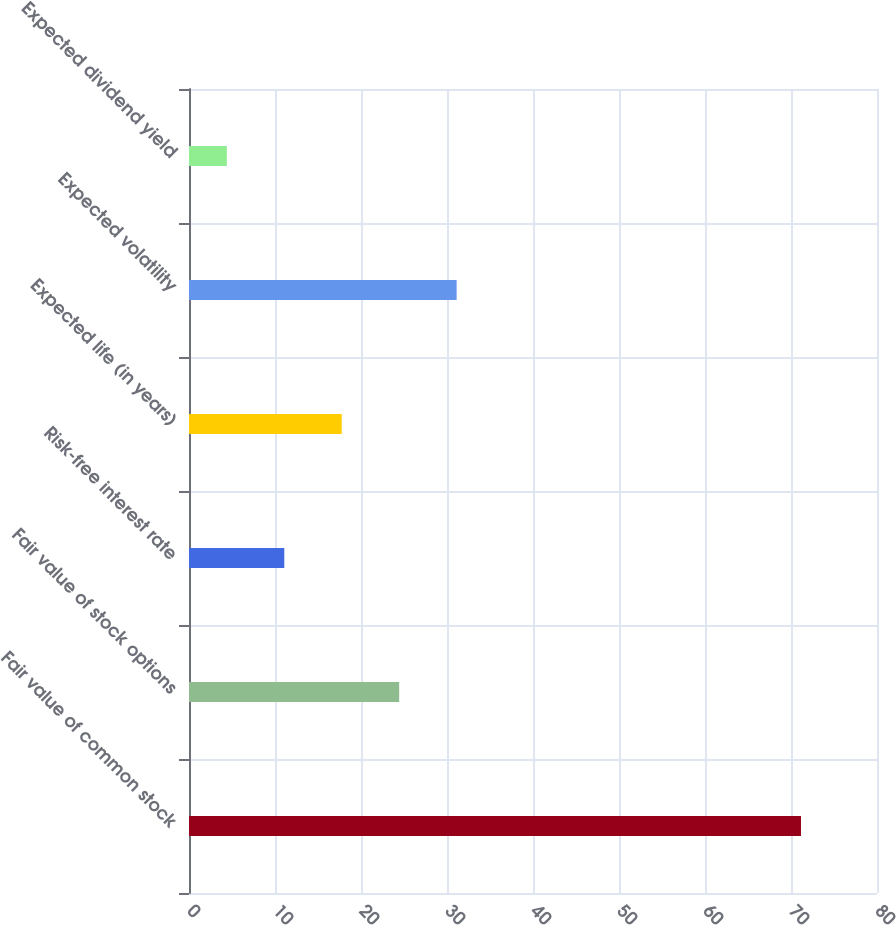Convert chart. <chart><loc_0><loc_0><loc_500><loc_500><bar_chart><fcel>Fair value of common stock<fcel>Fair value of stock options<fcel>Risk-free interest rate<fcel>Expected life (in years)<fcel>Expected volatility<fcel>Expected dividend yield<nl><fcel>71.16<fcel>24.44<fcel>11.08<fcel>17.76<fcel>31.12<fcel>4.4<nl></chart> 